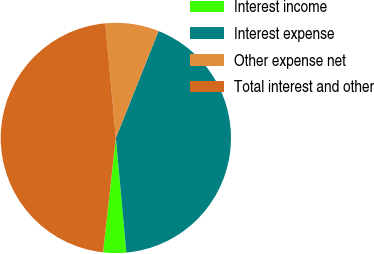Convert chart. <chart><loc_0><loc_0><loc_500><loc_500><pie_chart><fcel>Interest income<fcel>Interest expense<fcel>Other expense net<fcel>Total interest and other<nl><fcel>3.23%<fcel>42.5%<fcel>7.5%<fcel>46.77%<nl></chart> 